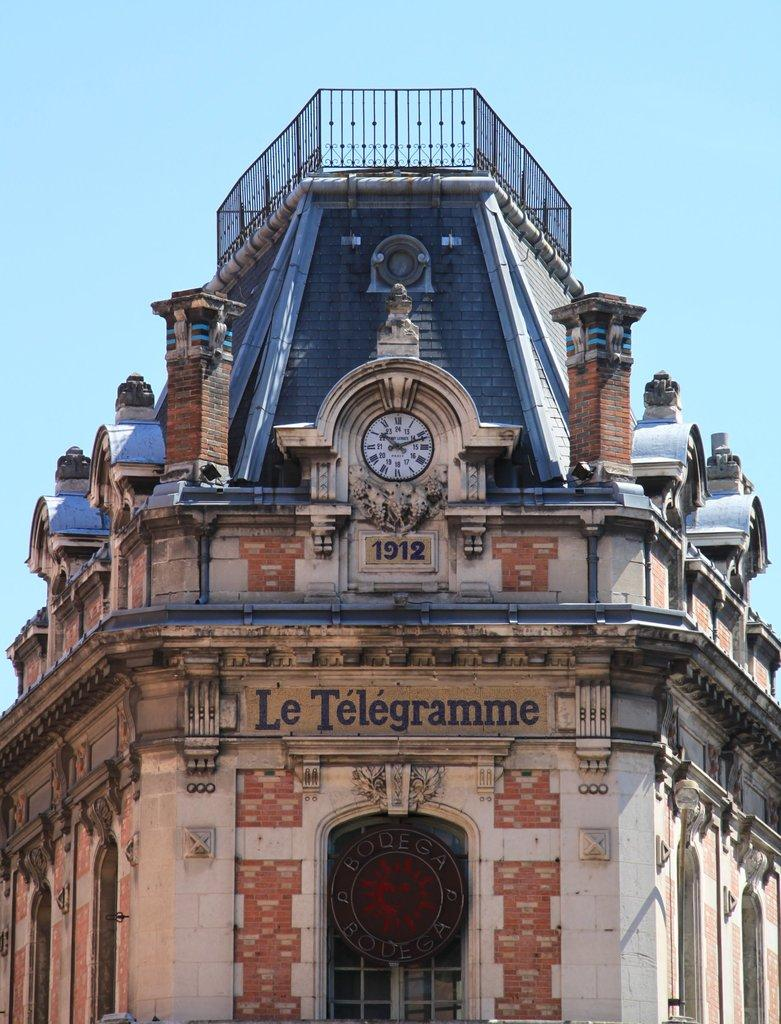What is the main subject in the foreground of the picture? There is a building in the foreground of the picture. What feature is present in the center of the building? There is a clock in the center of the building. What can be seen at the top of the building? There is railing at the top of the building. What is the condition of the sky in the picture? The sky is clear in the picture. What is the weather like in the image? It is sunny in the image. What type of songs can be heard playing from the grain in the image? There is no grain or songs present in the image; it features a building with a clock and railing. What kind of record is being set by the building in the image? There is no record being set by the building in the image; it is simply a building with a clock and railing. 